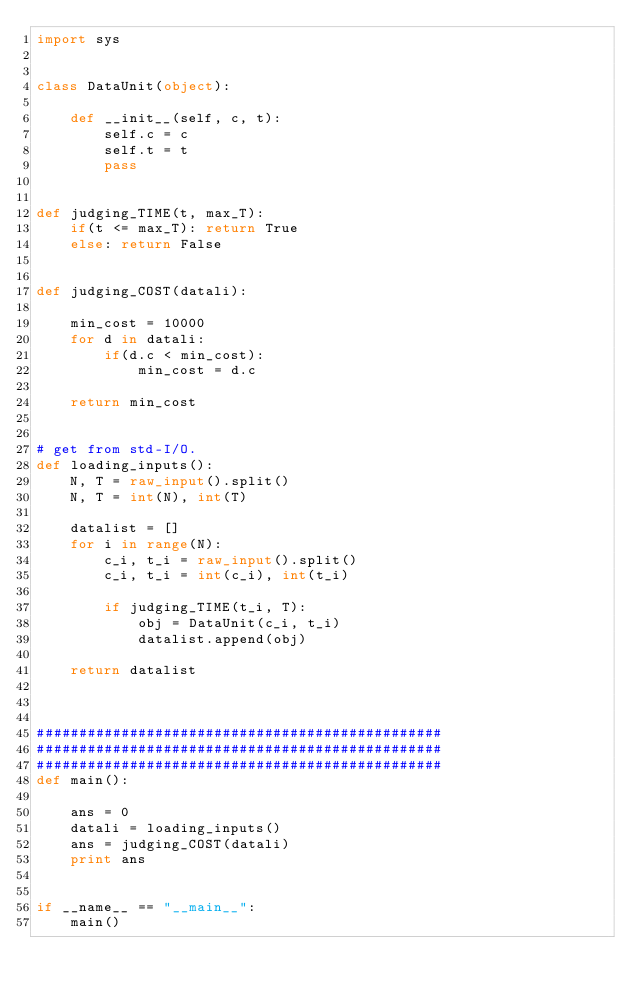<code> <loc_0><loc_0><loc_500><loc_500><_Python_>import sys


class DataUnit(object):

    def __init__(self, c, t):
        self.c = c
        self.t = t
        pass


def judging_TIME(t, max_T):
    if(t <= max_T): return True
    else: return False


def judging_COST(datali):

    min_cost = 10000
    for d in datali:
        if(d.c < min_cost):
            min_cost = d.c

    return min_cost


# get from std-I/O.
def loading_inputs():
    N, T = raw_input().split()
    N, T = int(N), int(T) 

    datalist = []
    for i in range(N):
        c_i, t_i = raw_input().split()
        c_i, t_i = int(c_i), int(t_i)

        if judging_TIME(t_i, T):
            obj = DataUnit(c_i, t_i)
            datalist.append(obj)

    return datalist



################################################
################################################
################################################
def main():

    ans = 0
    datali = loading_inputs()
    ans = judging_COST(datali)
    print ans


if __name__ == "__main__":
    main()



</code> 